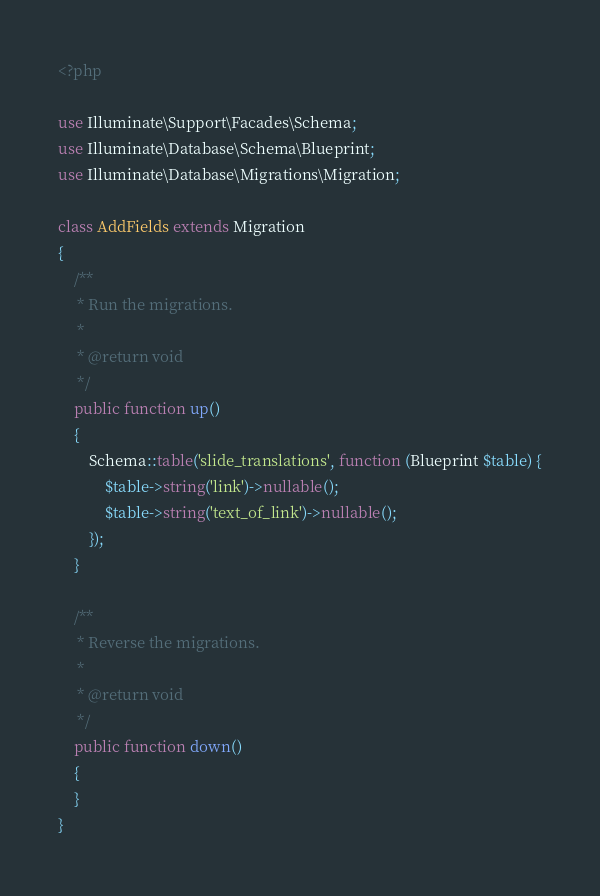<code> <loc_0><loc_0><loc_500><loc_500><_PHP_><?php

use Illuminate\Support\Facades\Schema;
use Illuminate\Database\Schema\Blueprint;
use Illuminate\Database\Migrations\Migration;

class AddFields extends Migration
{
    /**
     * Run the migrations.
     *
     * @return void
     */
    public function up()
    {
        Schema::table('slide_translations', function (Blueprint $table) {
            $table->string('link')->nullable();
            $table->string('text_of_link')->nullable();
        });
    }

    /**
     * Reverse the migrations.
     *
     * @return void
     */
    public function down()
    {
    }
}
</code> 